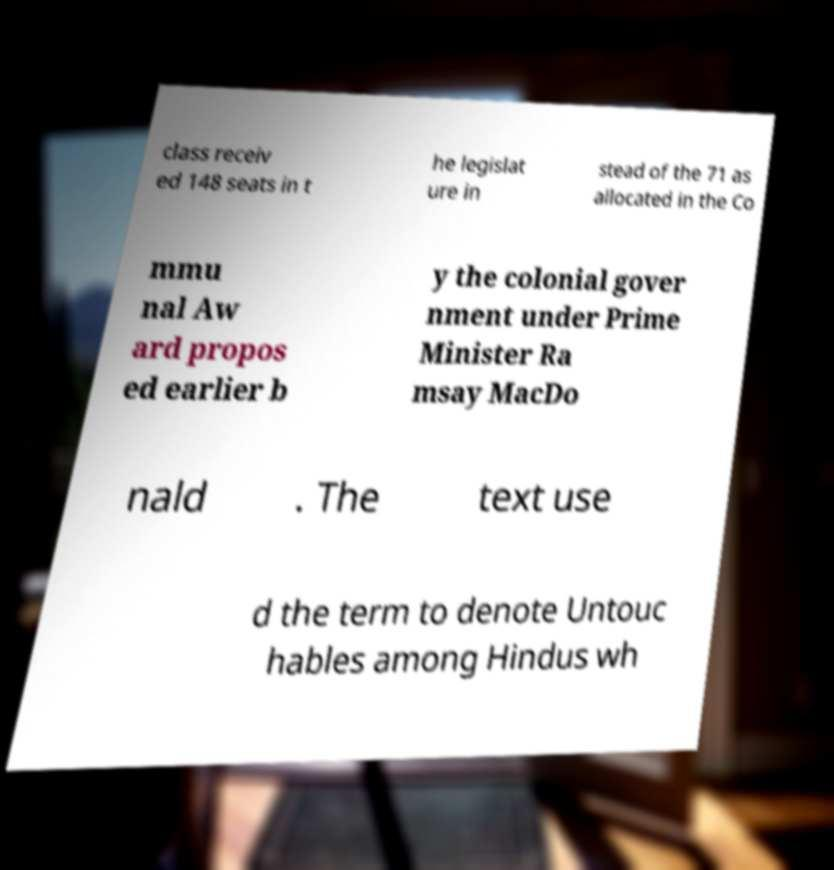Can you read and provide the text displayed in the image?This photo seems to have some interesting text. Can you extract and type it out for me? class receiv ed 148 seats in t he legislat ure in stead of the 71 as allocated in the Co mmu nal Aw ard propos ed earlier b y the colonial gover nment under Prime Minister Ra msay MacDo nald . The text use d the term to denote Untouc hables among Hindus wh 